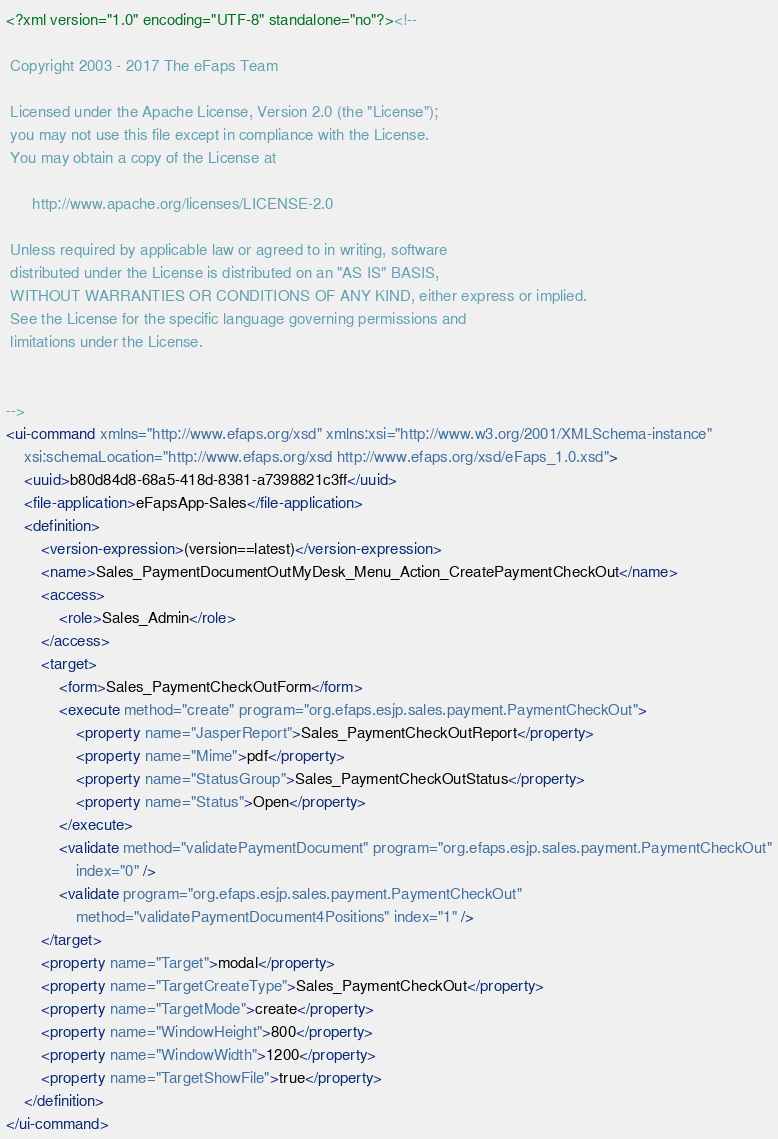Convert code to text. <code><loc_0><loc_0><loc_500><loc_500><_XML_><?xml version="1.0" encoding="UTF-8" standalone="no"?><!--

 Copyright 2003 - 2017 The eFaps Team

 Licensed under the Apache License, Version 2.0 (the "License");
 you may not use this file except in compliance with the License.
 You may obtain a copy of the License at

      http://www.apache.org/licenses/LICENSE-2.0

 Unless required by applicable law or agreed to in writing, software
 distributed under the License is distributed on an "AS IS" BASIS,
 WITHOUT WARRANTIES OR CONDITIONS OF ANY KIND, either express or implied.
 See the License for the specific language governing permissions and
 limitations under the License.


-->
<ui-command xmlns="http://www.efaps.org/xsd" xmlns:xsi="http://www.w3.org/2001/XMLSchema-instance"
    xsi:schemaLocation="http://www.efaps.org/xsd http://www.efaps.org/xsd/eFaps_1.0.xsd">
    <uuid>b80d84d8-68a5-418d-8381-a7398821c3ff</uuid>
    <file-application>eFapsApp-Sales</file-application>
    <definition>
        <version-expression>(version==latest)</version-expression>
        <name>Sales_PaymentDocumentOutMyDesk_Menu_Action_CreatePaymentCheckOut</name>
        <access>
            <role>Sales_Admin</role>
        </access>
        <target>
            <form>Sales_PaymentCheckOutForm</form>
            <execute method="create" program="org.efaps.esjp.sales.payment.PaymentCheckOut">
                <property name="JasperReport">Sales_PaymentCheckOutReport</property>
                <property name="Mime">pdf</property>
                <property name="StatusGroup">Sales_PaymentCheckOutStatus</property>
                <property name="Status">Open</property>
            </execute>
            <validate method="validatePaymentDocument" program="org.efaps.esjp.sales.payment.PaymentCheckOut"
                index="0" />
            <validate program="org.efaps.esjp.sales.payment.PaymentCheckOut"
                method="validatePaymentDocument4Positions" index="1" />
        </target>
        <property name="Target">modal</property>
        <property name="TargetCreateType">Sales_PaymentCheckOut</property>
        <property name="TargetMode">create</property>
        <property name="WindowHeight">800</property>
        <property name="WindowWidth">1200</property>
        <property name="TargetShowFile">true</property>
    </definition>
</ui-command>
</code> 